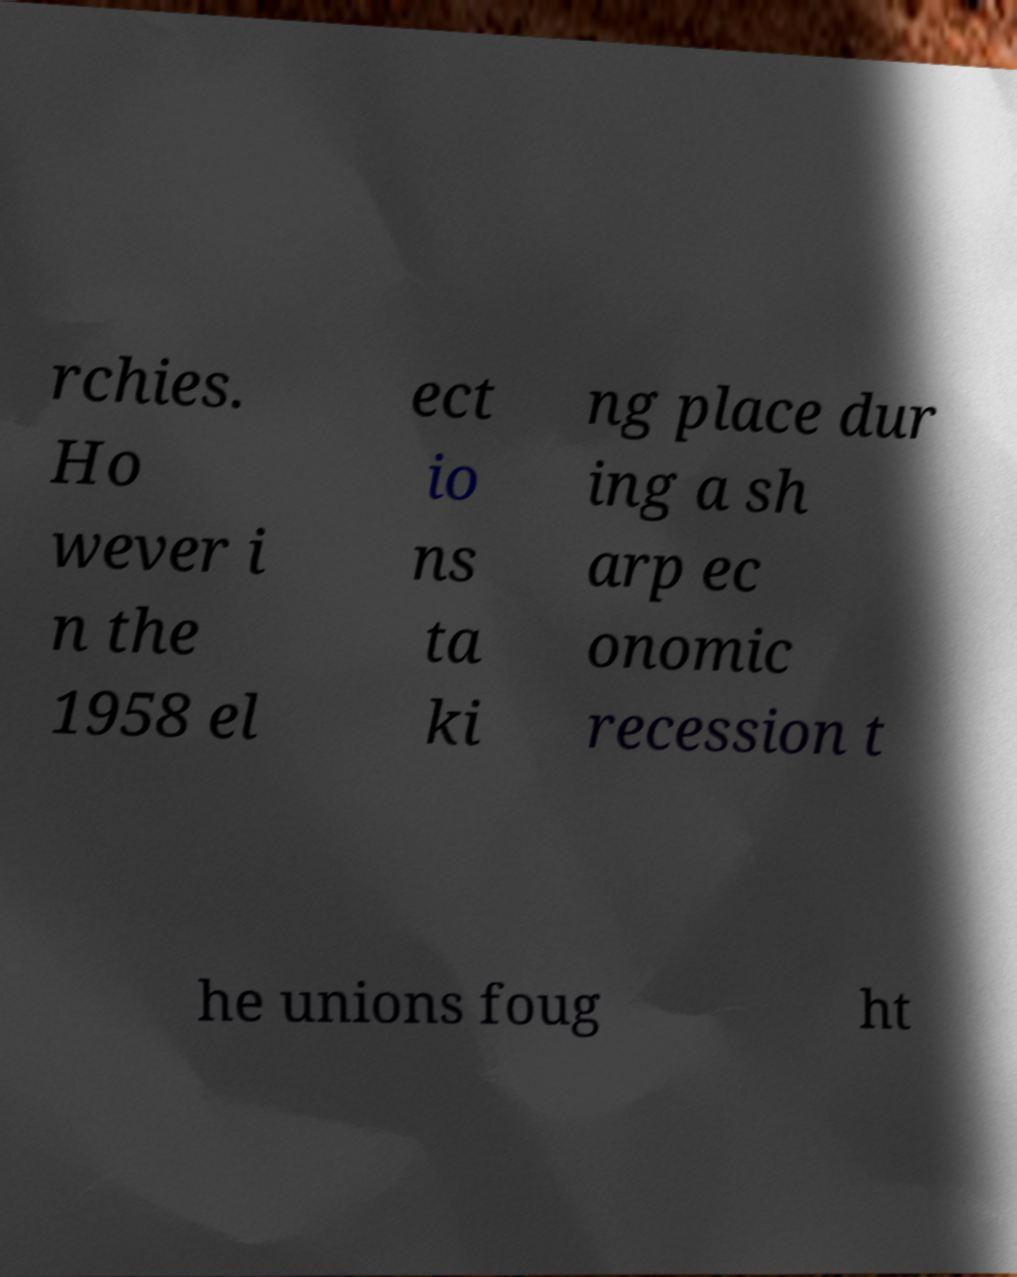For documentation purposes, I need the text within this image transcribed. Could you provide that? rchies. Ho wever i n the 1958 el ect io ns ta ki ng place dur ing a sh arp ec onomic recession t he unions foug ht 